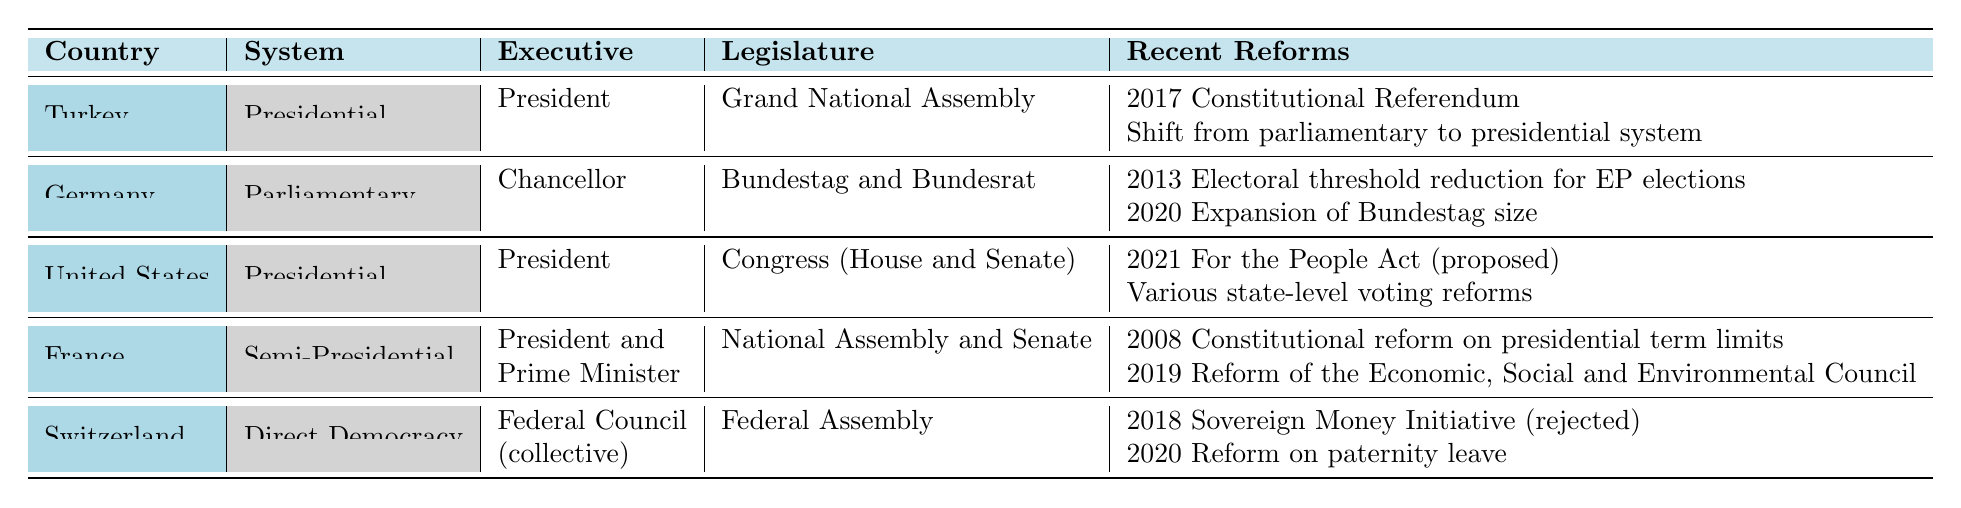What type of democratic system does Turkey have? Turkey's democratic system is explicitly mentioned in the table. The column for "System" indicates that Turkey has a "Presidential" system.
Answer: Presidential Who is the executive leader in Germany? The table shows the executive leader for Germany in the "Executive" column, which states that the executive is the "Chancellor."
Answer: Chancellor Does France have a parliamentary system? The table indicates that France has a "Semi-Presidential" system, not purely parliamentary, as noted in the "System" column.
Answer: No What are the main legislative bodies in the United States? In the "Legislature" column for the United States, it specifies the legislative bodies as "Congress (House and Senate)."
Answer: Congress (House and Senate) How many recent reforms are listed for Switzerland? By counting the items in the "Recent Reforms" column for Switzerland, we see there are two recent reforms listed: "2018 Sovereign Money Initiative (rejected)" and "2020 Reform on paternity leave."
Answer: 2 What is the difference between the executive structures of the United States and France? The executive structure for the United States is a single "President," while France has a dual structure with a "President and Prime Minister," illustrating a significant difference in their executive systems.
Answer: United States: President, France: President and Prime Minister Which country underwent a shift from a parliamentary to a presidential system? The table explicitly mentions in the recent reforms for Turkey that there was a "Shift from parliamentary to presidential system."
Answer: Turkey Which country has a mixed electoral system? The table indicates that Germany employs a "Mixed Member Proportional" electoral system, identified under the "Electoral System" column.
Answer: Germany What constitutional reform occurred in France in 2008? According to the recent reforms listed for France, the table states there was a "2008 Constitutional reform on presidential term limits," identifying the nature of the reform.
Answer: Presidential term limits Which country allows for direct democracy practices? The table specifies that Switzerland uses a "Direct Democracy" system, clearly indicating its approach to democratic practices.
Answer: Switzerland What are the two features of the judiciary across the five countries? The judiciary for each country is specified: Turkey has a "Constitutional Court," Germany has a "Federal Constitutional Court," the U.S. has a "Supreme Court," France has a "Constitutional Council," and Switzerland has a "Federal Supreme Court." There are various structures shown for each country.
Answer: Varies by country 